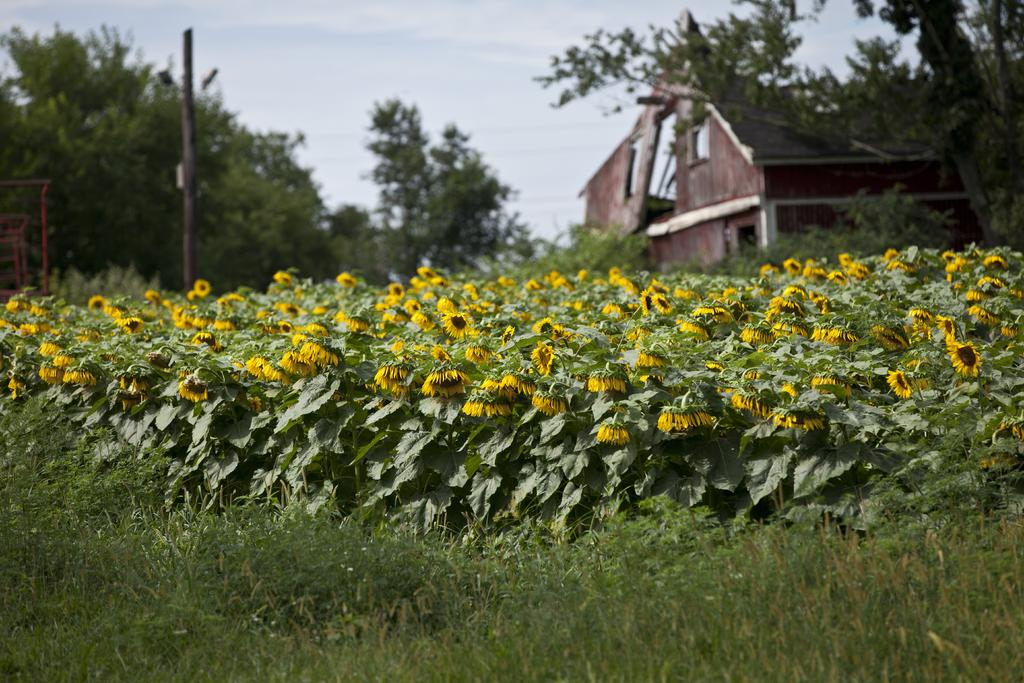What can be seen in the background of the image? In the background of the image, there is a sky, trees, and a house. What type of vegetation is present in the image? There is grass, plants, and flowers in the image. Are there any objects on the left side of the image? Yes, there are objects on the left side of the image. What type of quill is being used to write on the oven in the image? There is no quill or oven present in the image. What type of insurance is being discussed by the flowers in the image? There is no discussion of insurance in the image, and the flowers are not capable of discussing anything. 